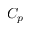<formula> <loc_0><loc_0><loc_500><loc_500>C _ { p }</formula> 